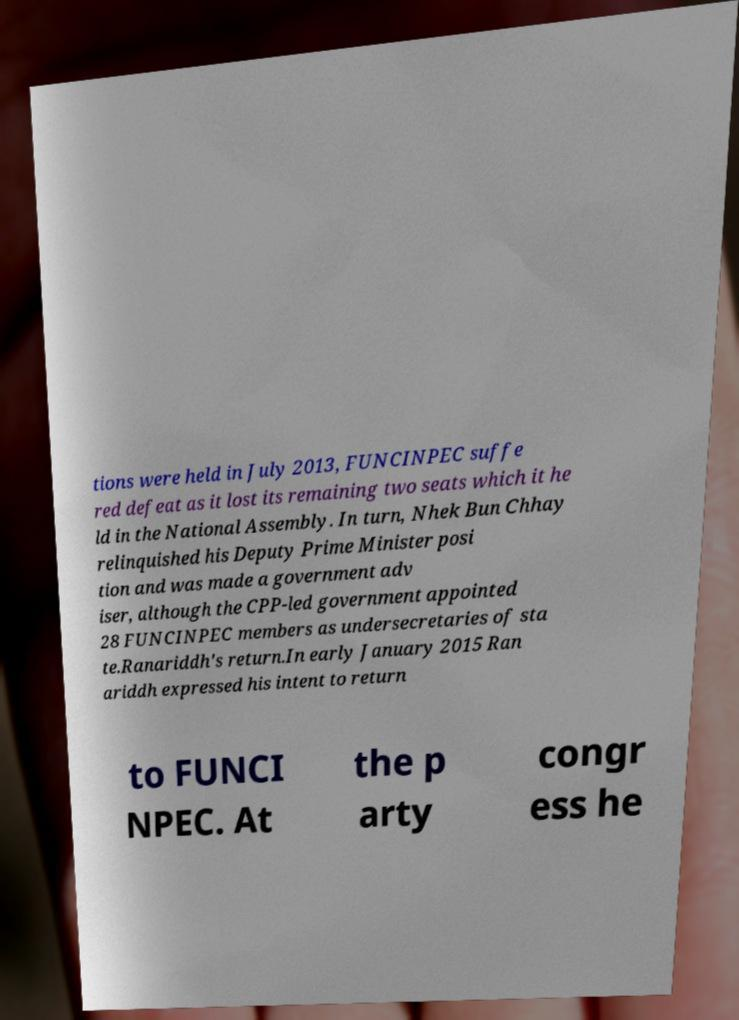Please identify and transcribe the text found in this image. tions were held in July 2013, FUNCINPEC suffe red defeat as it lost its remaining two seats which it he ld in the National Assembly. In turn, Nhek Bun Chhay relinquished his Deputy Prime Minister posi tion and was made a government adv iser, although the CPP-led government appointed 28 FUNCINPEC members as undersecretaries of sta te.Ranariddh's return.In early January 2015 Ran ariddh expressed his intent to return to FUNCI NPEC. At the p arty congr ess he 